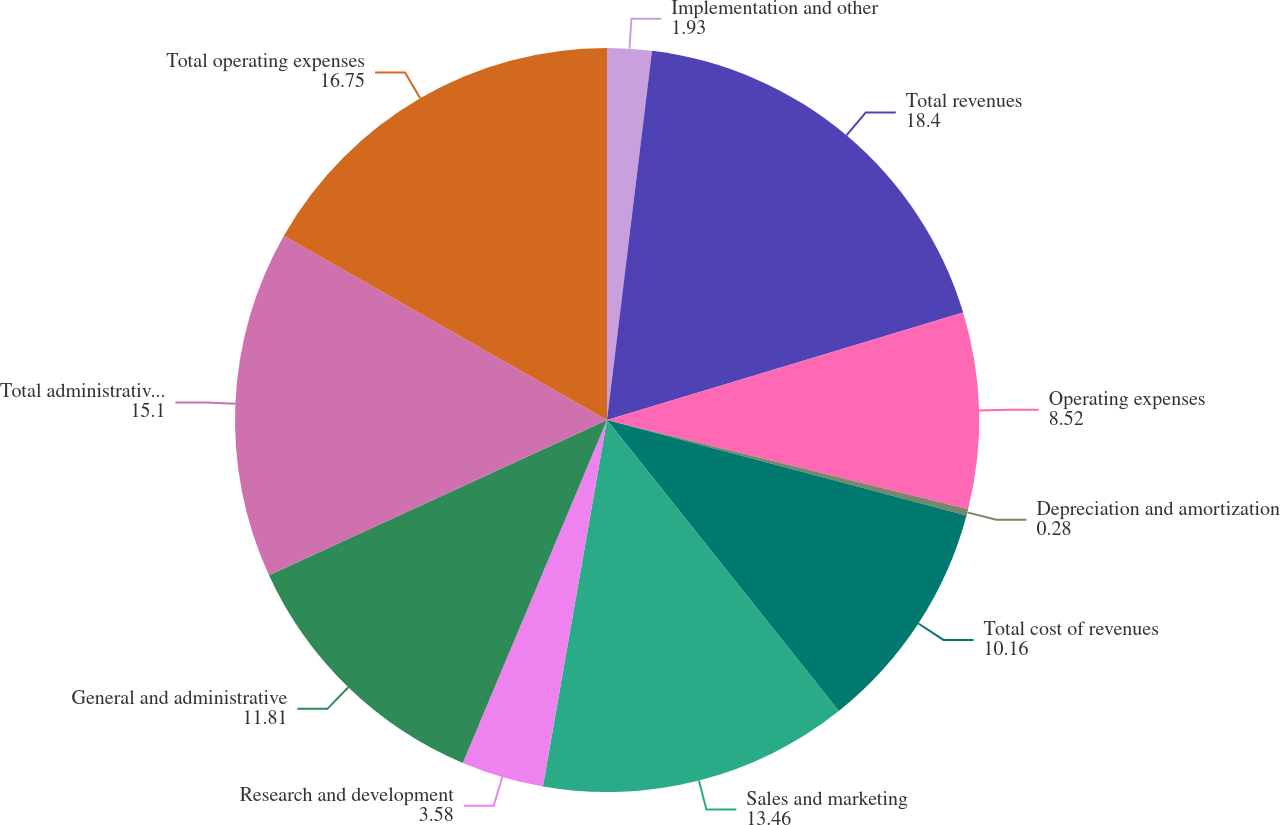Convert chart to OTSL. <chart><loc_0><loc_0><loc_500><loc_500><pie_chart><fcel>Implementation and other<fcel>Total revenues<fcel>Operating expenses<fcel>Depreciation and amortization<fcel>Total cost of revenues<fcel>Sales and marketing<fcel>Research and development<fcel>General and administrative<fcel>Total administrative expenses<fcel>Total operating expenses<nl><fcel>1.93%<fcel>18.4%<fcel>8.52%<fcel>0.28%<fcel>10.16%<fcel>13.46%<fcel>3.58%<fcel>11.81%<fcel>15.1%<fcel>16.75%<nl></chart> 